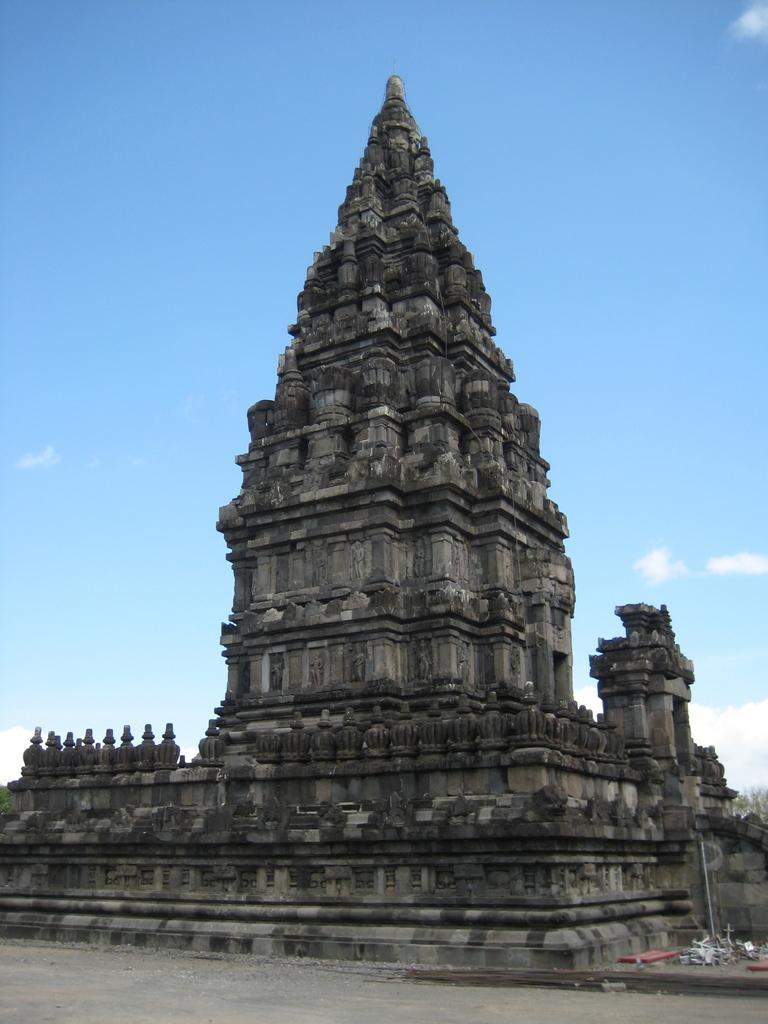Describe this image in one or two sentences. In this picture I can see a temple, there are some items, there are trees, and in the background there is sky. 